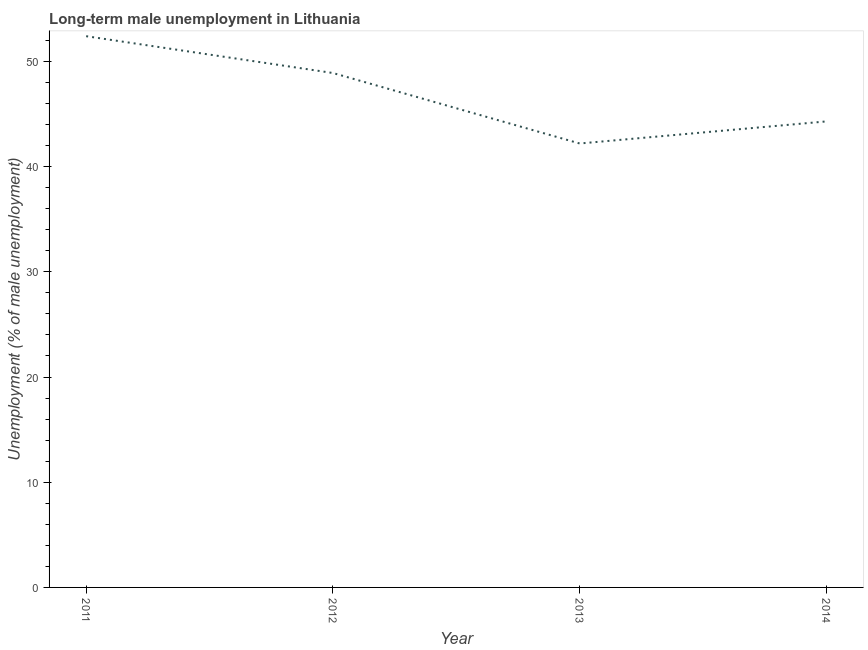What is the long-term male unemployment in 2014?
Give a very brief answer. 44.3. Across all years, what is the maximum long-term male unemployment?
Give a very brief answer. 52.4. Across all years, what is the minimum long-term male unemployment?
Keep it short and to the point. 42.2. In which year was the long-term male unemployment maximum?
Your answer should be very brief. 2011. What is the sum of the long-term male unemployment?
Provide a short and direct response. 187.8. What is the difference between the long-term male unemployment in 2012 and 2014?
Provide a succinct answer. 4.6. What is the average long-term male unemployment per year?
Give a very brief answer. 46.95. What is the median long-term male unemployment?
Provide a short and direct response. 46.6. What is the ratio of the long-term male unemployment in 2011 to that in 2013?
Keep it short and to the point. 1.24. Is the difference between the long-term male unemployment in 2012 and 2013 greater than the difference between any two years?
Your answer should be very brief. No. What is the difference between the highest and the second highest long-term male unemployment?
Ensure brevity in your answer.  3.5. What is the difference between the highest and the lowest long-term male unemployment?
Provide a succinct answer. 10.2. In how many years, is the long-term male unemployment greater than the average long-term male unemployment taken over all years?
Keep it short and to the point. 2. How many lines are there?
Your response must be concise. 1. How many years are there in the graph?
Provide a short and direct response. 4. Are the values on the major ticks of Y-axis written in scientific E-notation?
Provide a succinct answer. No. Does the graph contain grids?
Offer a very short reply. No. What is the title of the graph?
Your answer should be compact. Long-term male unemployment in Lithuania. What is the label or title of the X-axis?
Give a very brief answer. Year. What is the label or title of the Y-axis?
Your answer should be very brief. Unemployment (% of male unemployment). What is the Unemployment (% of male unemployment) in 2011?
Provide a succinct answer. 52.4. What is the Unemployment (% of male unemployment) of 2012?
Your answer should be very brief. 48.9. What is the Unemployment (% of male unemployment) of 2013?
Keep it short and to the point. 42.2. What is the Unemployment (% of male unemployment) of 2014?
Ensure brevity in your answer.  44.3. What is the difference between the Unemployment (% of male unemployment) in 2011 and 2013?
Your response must be concise. 10.2. What is the difference between the Unemployment (% of male unemployment) in 2012 and 2013?
Your response must be concise. 6.7. What is the ratio of the Unemployment (% of male unemployment) in 2011 to that in 2012?
Ensure brevity in your answer.  1.07. What is the ratio of the Unemployment (% of male unemployment) in 2011 to that in 2013?
Offer a very short reply. 1.24. What is the ratio of the Unemployment (% of male unemployment) in 2011 to that in 2014?
Offer a very short reply. 1.18. What is the ratio of the Unemployment (% of male unemployment) in 2012 to that in 2013?
Keep it short and to the point. 1.16. What is the ratio of the Unemployment (% of male unemployment) in 2012 to that in 2014?
Keep it short and to the point. 1.1. What is the ratio of the Unemployment (% of male unemployment) in 2013 to that in 2014?
Offer a terse response. 0.95. 